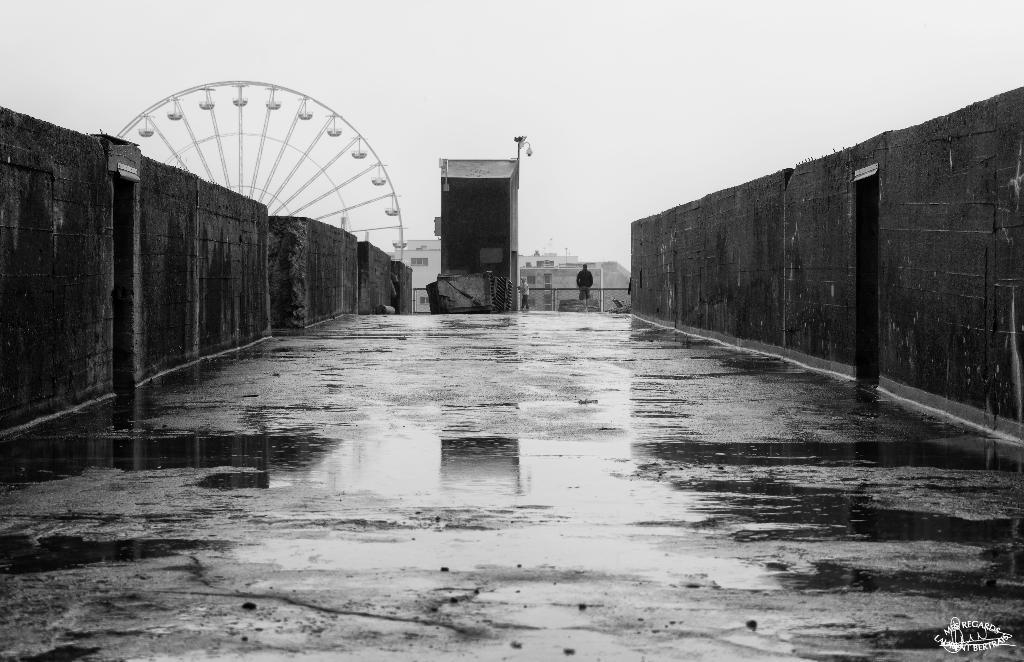What type of setting is depicted in the image? The image is an outdoor scene. What is the main feature in the image? There is a giant wheel in the image. What can be seen in the background of the image? There are many buildings visible in the distance. Are there any people in the image? Yes, a man is standing in the image. Can you see any lizards crawling on the giant wheel in the image? There are no lizards visible in the image, and they are not crawling on the giant wheel. 